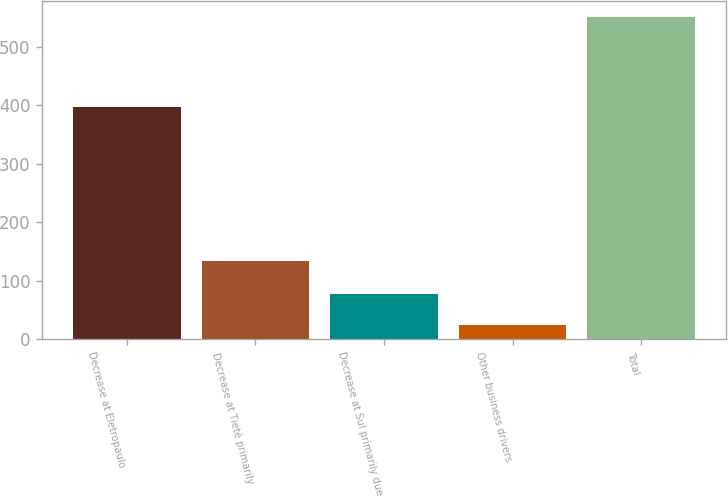Convert chart to OTSL. <chart><loc_0><loc_0><loc_500><loc_500><bar_chart><fcel>Decrease at Eletropaulo<fcel>Decrease at Tietê primarily<fcel>Decrease at Sul primarily due<fcel>Other business drivers<fcel>Total<nl><fcel>397<fcel>133<fcel>76.6<fcel>24<fcel>550<nl></chart> 